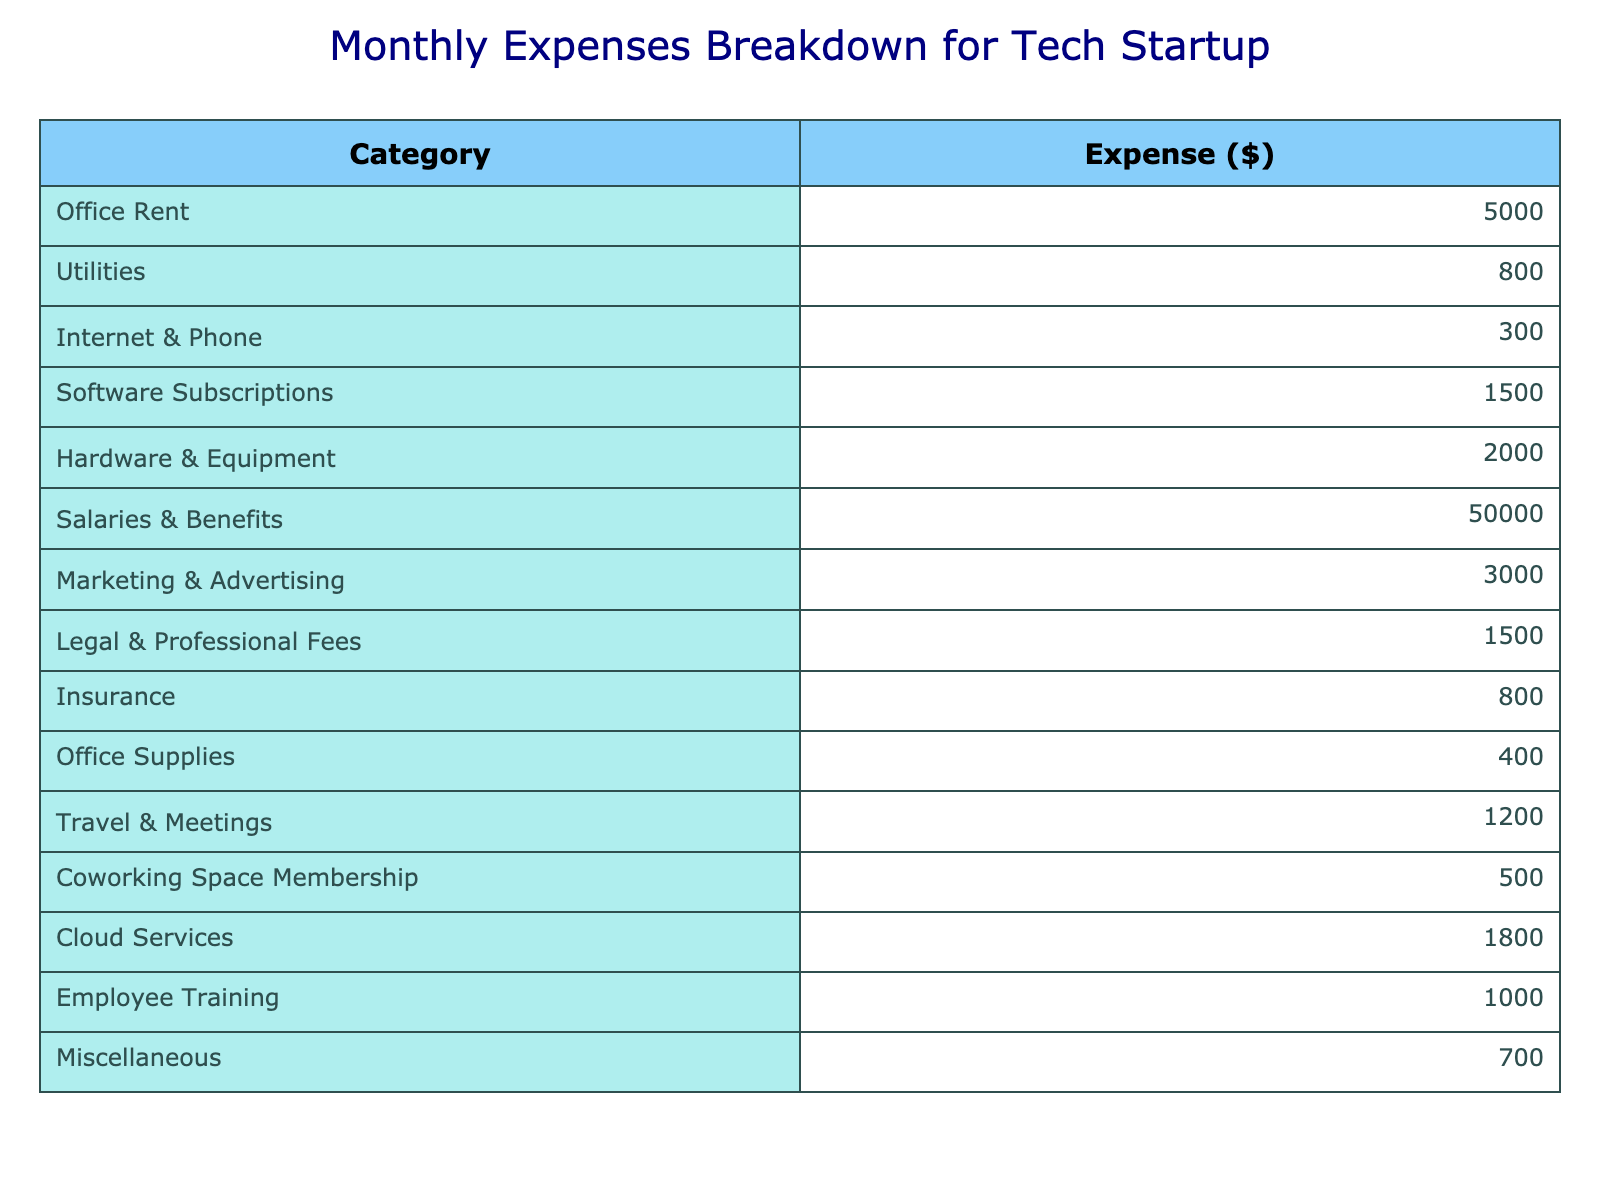What is the total monthly expense for the tech startup? To find the total, we need to sum all the expenses in the table: 5000 + 800 + 300 + 1500 + 2000 + 50000 + 3000 + 1500 + 800 + 400 + 1200 + 500 + 1800 + 1000 + 700 = 60200.
Answer: 60200 How much does the tech startup spend on salaries and benefits? The table shows that the expense for salaries and benefits is directly listed as 50000.
Answer: 50000 Is the expense for office rent higher than the expense for travel and meetings? The office rent is 5000 and travel and meetings expense is 1200. Since 5000 is greater than 1200, the statement is true.
Answer: Yes What are the combined costs of utilities and insurance? To find the combined costs, we add utilities (800) and insurance (800): 800 + 800 = 1600.
Answer: 1600 What is the difference in expense between software subscriptions and office supplies? Software subscriptions cost 1500, and office supplies cost 400. Subtracting gives us 1500 - 400 = 1100.
Answer: 1100 What percentage of the total expenses is spent on marketing and advertising? First, we calculate the total expenses as 60200. The marketing expense is 3000. To find the percentage, we divide the marketing expense by total expenses and multiply by 100: (3000 / 60200) * 100 = 4.98, approximately 5%.
Answer: 5% Does the tech startup allocate more funds to cloud services than to coworking space membership? Cloud services cost 1800, while coworking space membership is 500. Since 1800 is greater than 500, the statement is true.
Answer: Yes What is the total spent on hardware & equipment and employee training? The hardware & equipment expense is 2000, and employee training is 1000. To get the total: 2000 + 1000 = 3000.
Answer: 3000 What is the average amount spent per month on office expenses (office rent, utilities, office supplies)? First, identify the relevant expenses: office rent (5000), utilities (800), and office supplies (400). The sum is 5000 + 800 + 400 = 6200. The average is then 6200 / 3 = 2066.67, approximately 2067.
Answer: 2067 